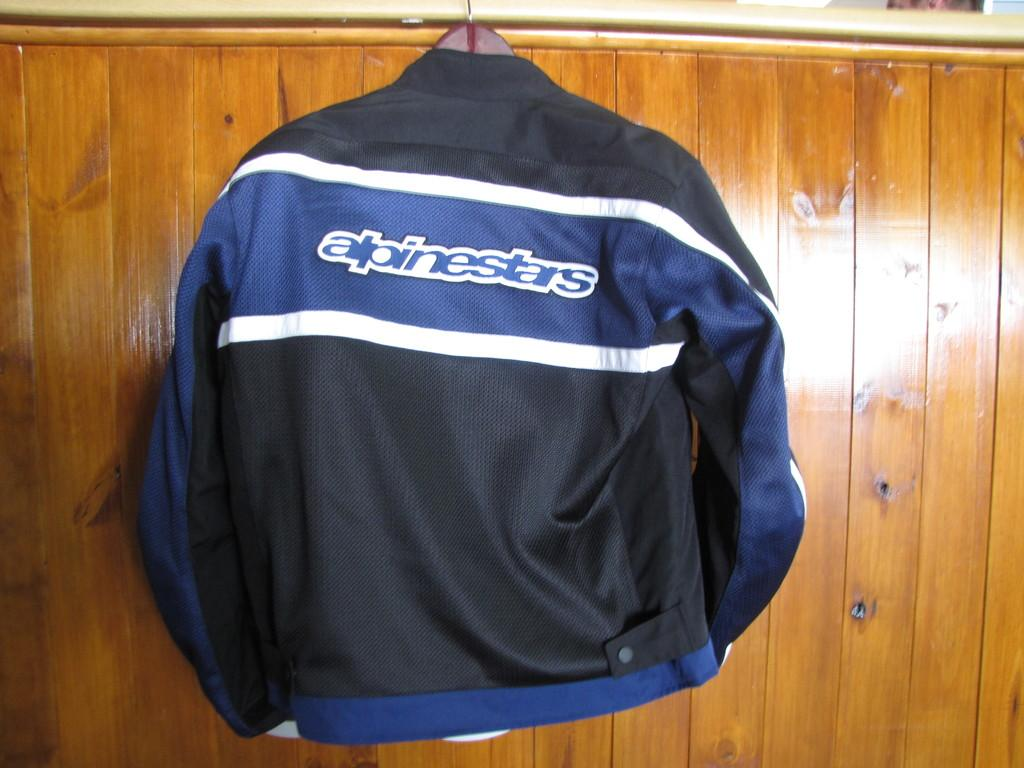<image>
Relay a brief, clear account of the picture shown. A blue and black jersey that says alpinestars. 